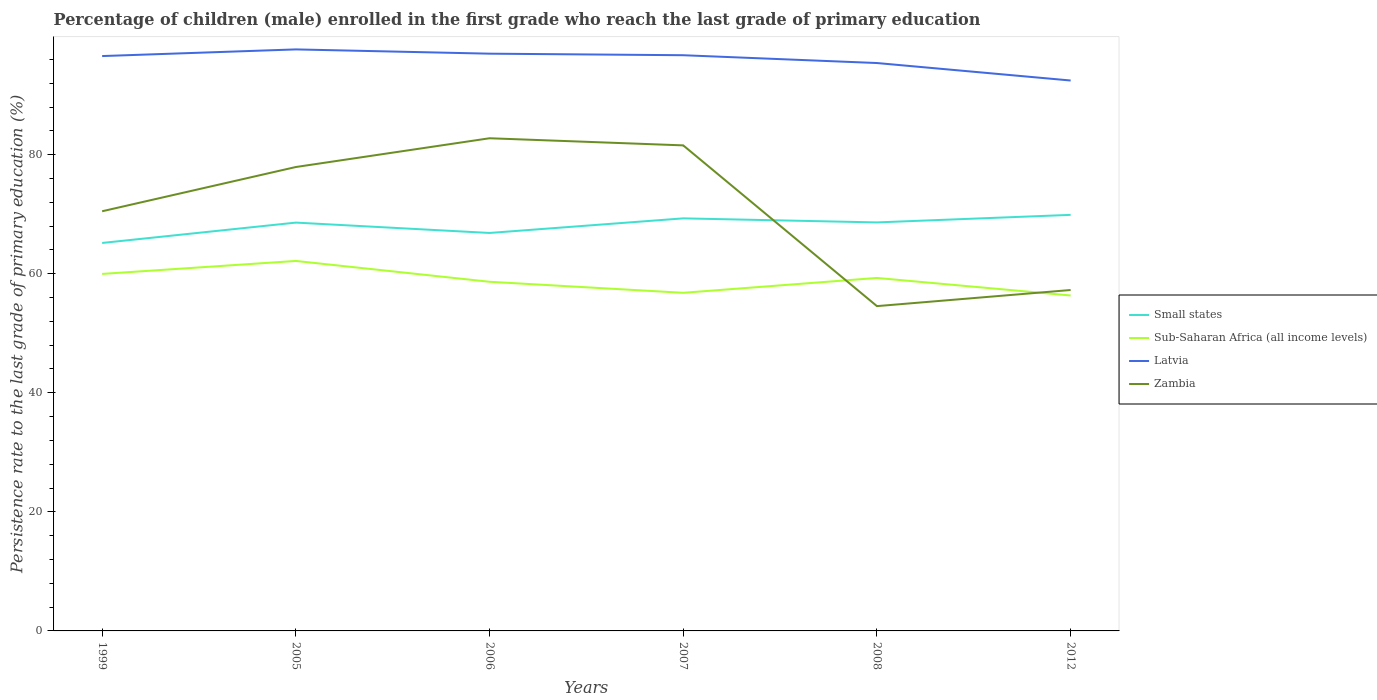Does the line corresponding to Latvia intersect with the line corresponding to Sub-Saharan Africa (all income levels)?
Make the answer very short. No. Is the number of lines equal to the number of legend labels?
Provide a succinct answer. Yes. Across all years, what is the maximum persistence rate of children in Sub-Saharan Africa (all income levels)?
Your answer should be very brief. 56.34. In which year was the persistence rate of children in Sub-Saharan Africa (all income levels) maximum?
Offer a terse response. 2012. What is the total persistence rate of children in Zambia in the graph?
Your answer should be very brief. -2.71. What is the difference between the highest and the second highest persistence rate of children in Latvia?
Provide a succinct answer. 5.23. How many years are there in the graph?
Provide a short and direct response. 6. Are the values on the major ticks of Y-axis written in scientific E-notation?
Your answer should be compact. No. Does the graph contain any zero values?
Give a very brief answer. No. How are the legend labels stacked?
Give a very brief answer. Vertical. What is the title of the graph?
Give a very brief answer. Percentage of children (male) enrolled in the first grade who reach the last grade of primary education. Does "Eritrea" appear as one of the legend labels in the graph?
Your answer should be compact. No. What is the label or title of the Y-axis?
Provide a short and direct response. Persistence rate to the last grade of primary education (%). What is the Persistence rate to the last grade of primary education (%) of Small states in 1999?
Give a very brief answer. 65.17. What is the Persistence rate to the last grade of primary education (%) of Sub-Saharan Africa (all income levels) in 1999?
Ensure brevity in your answer.  59.97. What is the Persistence rate to the last grade of primary education (%) in Latvia in 1999?
Keep it short and to the point. 96.56. What is the Persistence rate to the last grade of primary education (%) of Zambia in 1999?
Offer a terse response. 70.49. What is the Persistence rate to the last grade of primary education (%) in Small states in 2005?
Give a very brief answer. 68.59. What is the Persistence rate to the last grade of primary education (%) of Sub-Saharan Africa (all income levels) in 2005?
Your answer should be very brief. 62.15. What is the Persistence rate to the last grade of primary education (%) in Latvia in 2005?
Offer a very short reply. 97.68. What is the Persistence rate to the last grade of primary education (%) in Zambia in 2005?
Ensure brevity in your answer.  77.92. What is the Persistence rate to the last grade of primary education (%) of Small states in 2006?
Give a very brief answer. 66.85. What is the Persistence rate to the last grade of primary education (%) in Sub-Saharan Africa (all income levels) in 2006?
Your answer should be compact. 58.65. What is the Persistence rate to the last grade of primary education (%) in Latvia in 2006?
Ensure brevity in your answer.  96.96. What is the Persistence rate to the last grade of primary education (%) in Zambia in 2006?
Keep it short and to the point. 82.75. What is the Persistence rate to the last grade of primary education (%) of Small states in 2007?
Make the answer very short. 69.3. What is the Persistence rate to the last grade of primary education (%) of Sub-Saharan Africa (all income levels) in 2007?
Offer a very short reply. 56.8. What is the Persistence rate to the last grade of primary education (%) in Latvia in 2007?
Provide a succinct answer. 96.7. What is the Persistence rate to the last grade of primary education (%) in Zambia in 2007?
Give a very brief answer. 81.56. What is the Persistence rate to the last grade of primary education (%) in Small states in 2008?
Keep it short and to the point. 68.62. What is the Persistence rate to the last grade of primary education (%) in Sub-Saharan Africa (all income levels) in 2008?
Offer a very short reply. 59.29. What is the Persistence rate to the last grade of primary education (%) of Latvia in 2008?
Give a very brief answer. 95.39. What is the Persistence rate to the last grade of primary education (%) of Zambia in 2008?
Offer a very short reply. 54.56. What is the Persistence rate to the last grade of primary education (%) in Small states in 2012?
Provide a short and direct response. 69.89. What is the Persistence rate to the last grade of primary education (%) of Sub-Saharan Africa (all income levels) in 2012?
Make the answer very short. 56.34. What is the Persistence rate to the last grade of primary education (%) in Latvia in 2012?
Your answer should be compact. 92.45. What is the Persistence rate to the last grade of primary education (%) of Zambia in 2012?
Keep it short and to the point. 57.26. Across all years, what is the maximum Persistence rate to the last grade of primary education (%) of Small states?
Make the answer very short. 69.89. Across all years, what is the maximum Persistence rate to the last grade of primary education (%) in Sub-Saharan Africa (all income levels)?
Your answer should be very brief. 62.15. Across all years, what is the maximum Persistence rate to the last grade of primary education (%) of Latvia?
Your answer should be very brief. 97.68. Across all years, what is the maximum Persistence rate to the last grade of primary education (%) in Zambia?
Your answer should be very brief. 82.75. Across all years, what is the minimum Persistence rate to the last grade of primary education (%) in Small states?
Your response must be concise. 65.17. Across all years, what is the minimum Persistence rate to the last grade of primary education (%) of Sub-Saharan Africa (all income levels)?
Your answer should be very brief. 56.34. Across all years, what is the minimum Persistence rate to the last grade of primary education (%) in Latvia?
Your response must be concise. 92.45. Across all years, what is the minimum Persistence rate to the last grade of primary education (%) of Zambia?
Keep it short and to the point. 54.56. What is the total Persistence rate to the last grade of primary education (%) of Small states in the graph?
Give a very brief answer. 408.41. What is the total Persistence rate to the last grade of primary education (%) of Sub-Saharan Africa (all income levels) in the graph?
Give a very brief answer. 353.19. What is the total Persistence rate to the last grade of primary education (%) in Latvia in the graph?
Your answer should be compact. 575.74. What is the total Persistence rate to the last grade of primary education (%) of Zambia in the graph?
Your answer should be compact. 424.55. What is the difference between the Persistence rate to the last grade of primary education (%) in Small states in 1999 and that in 2005?
Ensure brevity in your answer.  -3.42. What is the difference between the Persistence rate to the last grade of primary education (%) in Sub-Saharan Africa (all income levels) in 1999 and that in 2005?
Provide a short and direct response. -2.18. What is the difference between the Persistence rate to the last grade of primary education (%) in Latvia in 1999 and that in 2005?
Provide a short and direct response. -1.12. What is the difference between the Persistence rate to the last grade of primary education (%) of Zambia in 1999 and that in 2005?
Make the answer very short. -7.43. What is the difference between the Persistence rate to the last grade of primary education (%) in Small states in 1999 and that in 2006?
Offer a terse response. -1.68. What is the difference between the Persistence rate to the last grade of primary education (%) in Sub-Saharan Africa (all income levels) in 1999 and that in 2006?
Give a very brief answer. 1.32. What is the difference between the Persistence rate to the last grade of primary education (%) of Latvia in 1999 and that in 2006?
Give a very brief answer. -0.4. What is the difference between the Persistence rate to the last grade of primary education (%) of Zambia in 1999 and that in 2006?
Make the answer very short. -12.26. What is the difference between the Persistence rate to the last grade of primary education (%) in Small states in 1999 and that in 2007?
Provide a short and direct response. -4.13. What is the difference between the Persistence rate to the last grade of primary education (%) in Sub-Saharan Africa (all income levels) in 1999 and that in 2007?
Your answer should be very brief. 3.17. What is the difference between the Persistence rate to the last grade of primary education (%) in Latvia in 1999 and that in 2007?
Make the answer very short. -0.14. What is the difference between the Persistence rate to the last grade of primary education (%) of Zambia in 1999 and that in 2007?
Your response must be concise. -11.07. What is the difference between the Persistence rate to the last grade of primary education (%) in Small states in 1999 and that in 2008?
Provide a short and direct response. -3.45. What is the difference between the Persistence rate to the last grade of primary education (%) in Sub-Saharan Africa (all income levels) in 1999 and that in 2008?
Your answer should be compact. 0.68. What is the difference between the Persistence rate to the last grade of primary education (%) of Latvia in 1999 and that in 2008?
Make the answer very short. 1.17. What is the difference between the Persistence rate to the last grade of primary education (%) of Zambia in 1999 and that in 2008?
Provide a short and direct response. 15.93. What is the difference between the Persistence rate to the last grade of primary education (%) in Small states in 1999 and that in 2012?
Keep it short and to the point. -4.72. What is the difference between the Persistence rate to the last grade of primary education (%) in Sub-Saharan Africa (all income levels) in 1999 and that in 2012?
Give a very brief answer. 3.63. What is the difference between the Persistence rate to the last grade of primary education (%) in Latvia in 1999 and that in 2012?
Keep it short and to the point. 4.11. What is the difference between the Persistence rate to the last grade of primary education (%) in Zambia in 1999 and that in 2012?
Make the answer very short. 13.23. What is the difference between the Persistence rate to the last grade of primary education (%) of Small states in 2005 and that in 2006?
Your answer should be very brief. 1.74. What is the difference between the Persistence rate to the last grade of primary education (%) of Sub-Saharan Africa (all income levels) in 2005 and that in 2006?
Provide a succinct answer. 3.5. What is the difference between the Persistence rate to the last grade of primary education (%) in Latvia in 2005 and that in 2006?
Make the answer very short. 0.72. What is the difference between the Persistence rate to the last grade of primary education (%) of Zambia in 2005 and that in 2006?
Make the answer very short. -4.83. What is the difference between the Persistence rate to the last grade of primary education (%) in Small states in 2005 and that in 2007?
Your answer should be compact. -0.71. What is the difference between the Persistence rate to the last grade of primary education (%) of Sub-Saharan Africa (all income levels) in 2005 and that in 2007?
Provide a succinct answer. 5.35. What is the difference between the Persistence rate to the last grade of primary education (%) in Zambia in 2005 and that in 2007?
Offer a very short reply. -3.63. What is the difference between the Persistence rate to the last grade of primary education (%) in Small states in 2005 and that in 2008?
Keep it short and to the point. -0.03. What is the difference between the Persistence rate to the last grade of primary education (%) in Sub-Saharan Africa (all income levels) in 2005 and that in 2008?
Your answer should be compact. 2.86. What is the difference between the Persistence rate to the last grade of primary education (%) of Latvia in 2005 and that in 2008?
Give a very brief answer. 2.29. What is the difference between the Persistence rate to the last grade of primary education (%) in Zambia in 2005 and that in 2008?
Offer a very short reply. 23.36. What is the difference between the Persistence rate to the last grade of primary education (%) in Small states in 2005 and that in 2012?
Keep it short and to the point. -1.3. What is the difference between the Persistence rate to the last grade of primary education (%) in Sub-Saharan Africa (all income levels) in 2005 and that in 2012?
Make the answer very short. 5.8. What is the difference between the Persistence rate to the last grade of primary education (%) in Latvia in 2005 and that in 2012?
Ensure brevity in your answer.  5.23. What is the difference between the Persistence rate to the last grade of primary education (%) of Zambia in 2005 and that in 2012?
Offer a very short reply. 20.66. What is the difference between the Persistence rate to the last grade of primary education (%) in Small states in 2006 and that in 2007?
Your answer should be compact. -2.45. What is the difference between the Persistence rate to the last grade of primary education (%) of Sub-Saharan Africa (all income levels) in 2006 and that in 2007?
Your response must be concise. 1.85. What is the difference between the Persistence rate to the last grade of primary education (%) in Latvia in 2006 and that in 2007?
Provide a succinct answer. 0.26. What is the difference between the Persistence rate to the last grade of primary education (%) of Zambia in 2006 and that in 2007?
Provide a short and direct response. 1.2. What is the difference between the Persistence rate to the last grade of primary education (%) of Small states in 2006 and that in 2008?
Provide a short and direct response. -1.77. What is the difference between the Persistence rate to the last grade of primary education (%) in Sub-Saharan Africa (all income levels) in 2006 and that in 2008?
Your answer should be compact. -0.64. What is the difference between the Persistence rate to the last grade of primary education (%) of Latvia in 2006 and that in 2008?
Make the answer very short. 1.57. What is the difference between the Persistence rate to the last grade of primary education (%) of Zambia in 2006 and that in 2008?
Keep it short and to the point. 28.2. What is the difference between the Persistence rate to the last grade of primary education (%) of Small states in 2006 and that in 2012?
Your answer should be very brief. -3.04. What is the difference between the Persistence rate to the last grade of primary education (%) in Sub-Saharan Africa (all income levels) in 2006 and that in 2012?
Your answer should be compact. 2.3. What is the difference between the Persistence rate to the last grade of primary education (%) in Latvia in 2006 and that in 2012?
Offer a very short reply. 4.51. What is the difference between the Persistence rate to the last grade of primary education (%) in Zambia in 2006 and that in 2012?
Offer a terse response. 25.49. What is the difference between the Persistence rate to the last grade of primary education (%) of Small states in 2007 and that in 2008?
Make the answer very short. 0.68. What is the difference between the Persistence rate to the last grade of primary education (%) in Sub-Saharan Africa (all income levels) in 2007 and that in 2008?
Your answer should be compact. -2.5. What is the difference between the Persistence rate to the last grade of primary education (%) in Latvia in 2007 and that in 2008?
Keep it short and to the point. 1.31. What is the difference between the Persistence rate to the last grade of primary education (%) in Zambia in 2007 and that in 2008?
Your answer should be very brief. 27. What is the difference between the Persistence rate to the last grade of primary education (%) in Small states in 2007 and that in 2012?
Give a very brief answer. -0.59. What is the difference between the Persistence rate to the last grade of primary education (%) in Sub-Saharan Africa (all income levels) in 2007 and that in 2012?
Offer a very short reply. 0.45. What is the difference between the Persistence rate to the last grade of primary education (%) of Latvia in 2007 and that in 2012?
Make the answer very short. 4.25. What is the difference between the Persistence rate to the last grade of primary education (%) in Zambia in 2007 and that in 2012?
Your response must be concise. 24.29. What is the difference between the Persistence rate to the last grade of primary education (%) of Small states in 2008 and that in 2012?
Your answer should be compact. -1.27. What is the difference between the Persistence rate to the last grade of primary education (%) in Sub-Saharan Africa (all income levels) in 2008 and that in 2012?
Ensure brevity in your answer.  2.95. What is the difference between the Persistence rate to the last grade of primary education (%) of Latvia in 2008 and that in 2012?
Keep it short and to the point. 2.94. What is the difference between the Persistence rate to the last grade of primary education (%) in Zambia in 2008 and that in 2012?
Your response must be concise. -2.71. What is the difference between the Persistence rate to the last grade of primary education (%) in Small states in 1999 and the Persistence rate to the last grade of primary education (%) in Sub-Saharan Africa (all income levels) in 2005?
Provide a succinct answer. 3.02. What is the difference between the Persistence rate to the last grade of primary education (%) of Small states in 1999 and the Persistence rate to the last grade of primary education (%) of Latvia in 2005?
Make the answer very short. -32.51. What is the difference between the Persistence rate to the last grade of primary education (%) in Small states in 1999 and the Persistence rate to the last grade of primary education (%) in Zambia in 2005?
Your answer should be very brief. -12.76. What is the difference between the Persistence rate to the last grade of primary education (%) in Sub-Saharan Africa (all income levels) in 1999 and the Persistence rate to the last grade of primary education (%) in Latvia in 2005?
Provide a short and direct response. -37.71. What is the difference between the Persistence rate to the last grade of primary education (%) in Sub-Saharan Africa (all income levels) in 1999 and the Persistence rate to the last grade of primary education (%) in Zambia in 2005?
Offer a terse response. -17.95. What is the difference between the Persistence rate to the last grade of primary education (%) of Latvia in 1999 and the Persistence rate to the last grade of primary education (%) of Zambia in 2005?
Keep it short and to the point. 18.64. What is the difference between the Persistence rate to the last grade of primary education (%) in Small states in 1999 and the Persistence rate to the last grade of primary education (%) in Sub-Saharan Africa (all income levels) in 2006?
Provide a short and direct response. 6.52. What is the difference between the Persistence rate to the last grade of primary education (%) in Small states in 1999 and the Persistence rate to the last grade of primary education (%) in Latvia in 2006?
Your answer should be very brief. -31.79. What is the difference between the Persistence rate to the last grade of primary education (%) of Small states in 1999 and the Persistence rate to the last grade of primary education (%) of Zambia in 2006?
Ensure brevity in your answer.  -17.59. What is the difference between the Persistence rate to the last grade of primary education (%) in Sub-Saharan Africa (all income levels) in 1999 and the Persistence rate to the last grade of primary education (%) in Latvia in 2006?
Keep it short and to the point. -36.99. What is the difference between the Persistence rate to the last grade of primary education (%) in Sub-Saharan Africa (all income levels) in 1999 and the Persistence rate to the last grade of primary education (%) in Zambia in 2006?
Keep it short and to the point. -22.79. What is the difference between the Persistence rate to the last grade of primary education (%) in Latvia in 1999 and the Persistence rate to the last grade of primary education (%) in Zambia in 2006?
Ensure brevity in your answer.  13.81. What is the difference between the Persistence rate to the last grade of primary education (%) in Small states in 1999 and the Persistence rate to the last grade of primary education (%) in Sub-Saharan Africa (all income levels) in 2007?
Make the answer very short. 8.37. What is the difference between the Persistence rate to the last grade of primary education (%) in Small states in 1999 and the Persistence rate to the last grade of primary education (%) in Latvia in 2007?
Keep it short and to the point. -31.53. What is the difference between the Persistence rate to the last grade of primary education (%) in Small states in 1999 and the Persistence rate to the last grade of primary education (%) in Zambia in 2007?
Ensure brevity in your answer.  -16.39. What is the difference between the Persistence rate to the last grade of primary education (%) of Sub-Saharan Africa (all income levels) in 1999 and the Persistence rate to the last grade of primary education (%) of Latvia in 2007?
Give a very brief answer. -36.73. What is the difference between the Persistence rate to the last grade of primary education (%) in Sub-Saharan Africa (all income levels) in 1999 and the Persistence rate to the last grade of primary education (%) in Zambia in 2007?
Your response must be concise. -21.59. What is the difference between the Persistence rate to the last grade of primary education (%) in Latvia in 1999 and the Persistence rate to the last grade of primary education (%) in Zambia in 2007?
Give a very brief answer. 15. What is the difference between the Persistence rate to the last grade of primary education (%) of Small states in 1999 and the Persistence rate to the last grade of primary education (%) of Sub-Saharan Africa (all income levels) in 2008?
Give a very brief answer. 5.88. What is the difference between the Persistence rate to the last grade of primary education (%) of Small states in 1999 and the Persistence rate to the last grade of primary education (%) of Latvia in 2008?
Keep it short and to the point. -30.22. What is the difference between the Persistence rate to the last grade of primary education (%) of Small states in 1999 and the Persistence rate to the last grade of primary education (%) of Zambia in 2008?
Provide a succinct answer. 10.61. What is the difference between the Persistence rate to the last grade of primary education (%) in Sub-Saharan Africa (all income levels) in 1999 and the Persistence rate to the last grade of primary education (%) in Latvia in 2008?
Your response must be concise. -35.42. What is the difference between the Persistence rate to the last grade of primary education (%) in Sub-Saharan Africa (all income levels) in 1999 and the Persistence rate to the last grade of primary education (%) in Zambia in 2008?
Give a very brief answer. 5.41. What is the difference between the Persistence rate to the last grade of primary education (%) in Latvia in 1999 and the Persistence rate to the last grade of primary education (%) in Zambia in 2008?
Offer a very short reply. 42. What is the difference between the Persistence rate to the last grade of primary education (%) of Small states in 1999 and the Persistence rate to the last grade of primary education (%) of Sub-Saharan Africa (all income levels) in 2012?
Provide a succinct answer. 8.82. What is the difference between the Persistence rate to the last grade of primary education (%) of Small states in 1999 and the Persistence rate to the last grade of primary education (%) of Latvia in 2012?
Keep it short and to the point. -27.28. What is the difference between the Persistence rate to the last grade of primary education (%) in Small states in 1999 and the Persistence rate to the last grade of primary education (%) in Zambia in 2012?
Keep it short and to the point. 7.9. What is the difference between the Persistence rate to the last grade of primary education (%) of Sub-Saharan Africa (all income levels) in 1999 and the Persistence rate to the last grade of primary education (%) of Latvia in 2012?
Your answer should be compact. -32.48. What is the difference between the Persistence rate to the last grade of primary education (%) in Sub-Saharan Africa (all income levels) in 1999 and the Persistence rate to the last grade of primary education (%) in Zambia in 2012?
Your response must be concise. 2.71. What is the difference between the Persistence rate to the last grade of primary education (%) of Latvia in 1999 and the Persistence rate to the last grade of primary education (%) of Zambia in 2012?
Offer a very short reply. 39.3. What is the difference between the Persistence rate to the last grade of primary education (%) of Small states in 2005 and the Persistence rate to the last grade of primary education (%) of Sub-Saharan Africa (all income levels) in 2006?
Provide a short and direct response. 9.94. What is the difference between the Persistence rate to the last grade of primary education (%) of Small states in 2005 and the Persistence rate to the last grade of primary education (%) of Latvia in 2006?
Your answer should be very brief. -28.37. What is the difference between the Persistence rate to the last grade of primary education (%) in Small states in 2005 and the Persistence rate to the last grade of primary education (%) in Zambia in 2006?
Provide a succinct answer. -14.17. What is the difference between the Persistence rate to the last grade of primary education (%) of Sub-Saharan Africa (all income levels) in 2005 and the Persistence rate to the last grade of primary education (%) of Latvia in 2006?
Make the answer very short. -34.81. What is the difference between the Persistence rate to the last grade of primary education (%) of Sub-Saharan Africa (all income levels) in 2005 and the Persistence rate to the last grade of primary education (%) of Zambia in 2006?
Give a very brief answer. -20.61. What is the difference between the Persistence rate to the last grade of primary education (%) of Latvia in 2005 and the Persistence rate to the last grade of primary education (%) of Zambia in 2006?
Offer a terse response. 14.92. What is the difference between the Persistence rate to the last grade of primary education (%) of Small states in 2005 and the Persistence rate to the last grade of primary education (%) of Sub-Saharan Africa (all income levels) in 2007?
Give a very brief answer. 11.79. What is the difference between the Persistence rate to the last grade of primary education (%) of Small states in 2005 and the Persistence rate to the last grade of primary education (%) of Latvia in 2007?
Your answer should be very brief. -28.11. What is the difference between the Persistence rate to the last grade of primary education (%) of Small states in 2005 and the Persistence rate to the last grade of primary education (%) of Zambia in 2007?
Your answer should be compact. -12.97. What is the difference between the Persistence rate to the last grade of primary education (%) in Sub-Saharan Africa (all income levels) in 2005 and the Persistence rate to the last grade of primary education (%) in Latvia in 2007?
Make the answer very short. -34.55. What is the difference between the Persistence rate to the last grade of primary education (%) in Sub-Saharan Africa (all income levels) in 2005 and the Persistence rate to the last grade of primary education (%) in Zambia in 2007?
Provide a succinct answer. -19.41. What is the difference between the Persistence rate to the last grade of primary education (%) in Latvia in 2005 and the Persistence rate to the last grade of primary education (%) in Zambia in 2007?
Your response must be concise. 16.12. What is the difference between the Persistence rate to the last grade of primary education (%) in Small states in 2005 and the Persistence rate to the last grade of primary education (%) in Sub-Saharan Africa (all income levels) in 2008?
Keep it short and to the point. 9.3. What is the difference between the Persistence rate to the last grade of primary education (%) of Small states in 2005 and the Persistence rate to the last grade of primary education (%) of Latvia in 2008?
Offer a very short reply. -26.8. What is the difference between the Persistence rate to the last grade of primary education (%) of Small states in 2005 and the Persistence rate to the last grade of primary education (%) of Zambia in 2008?
Give a very brief answer. 14.03. What is the difference between the Persistence rate to the last grade of primary education (%) in Sub-Saharan Africa (all income levels) in 2005 and the Persistence rate to the last grade of primary education (%) in Latvia in 2008?
Offer a very short reply. -33.24. What is the difference between the Persistence rate to the last grade of primary education (%) in Sub-Saharan Africa (all income levels) in 2005 and the Persistence rate to the last grade of primary education (%) in Zambia in 2008?
Offer a very short reply. 7.59. What is the difference between the Persistence rate to the last grade of primary education (%) in Latvia in 2005 and the Persistence rate to the last grade of primary education (%) in Zambia in 2008?
Keep it short and to the point. 43.12. What is the difference between the Persistence rate to the last grade of primary education (%) in Small states in 2005 and the Persistence rate to the last grade of primary education (%) in Sub-Saharan Africa (all income levels) in 2012?
Your response must be concise. 12.24. What is the difference between the Persistence rate to the last grade of primary education (%) in Small states in 2005 and the Persistence rate to the last grade of primary education (%) in Latvia in 2012?
Provide a short and direct response. -23.87. What is the difference between the Persistence rate to the last grade of primary education (%) in Small states in 2005 and the Persistence rate to the last grade of primary education (%) in Zambia in 2012?
Make the answer very short. 11.32. What is the difference between the Persistence rate to the last grade of primary education (%) in Sub-Saharan Africa (all income levels) in 2005 and the Persistence rate to the last grade of primary education (%) in Latvia in 2012?
Offer a terse response. -30.31. What is the difference between the Persistence rate to the last grade of primary education (%) in Sub-Saharan Africa (all income levels) in 2005 and the Persistence rate to the last grade of primary education (%) in Zambia in 2012?
Offer a terse response. 4.88. What is the difference between the Persistence rate to the last grade of primary education (%) in Latvia in 2005 and the Persistence rate to the last grade of primary education (%) in Zambia in 2012?
Your answer should be compact. 40.41. What is the difference between the Persistence rate to the last grade of primary education (%) of Small states in 2006 and the Persistence rate to the last grade of primary education (%) of Sub-Saharan Africa (all income levels) in 2007?
Your response must be concise. 10.05. What is the difference between the Persistence rate to the last grade of primary education (%) in Small states in 2006 and the Persistence rate to the last grade of primary education (%) in Latvia in 2007?
Keep it short and to the point. -29.85. What is the difference between the Persistence rate to the last grade of primary education (%) in Small states in 2006 and the Persistence rate to the last grade of primary education (%) in Zambia in 2007?
Offer a very short reply. -14.71. What is the difference between the Persistence rate to the last grade of primary education (%) in Sub-Saharan Africa (all income levels) in 2006 and the Persistence rate to the last grade of primary education (%) in Latvia in 2007?
Provide a short and direct response. -38.05. What is the difference between the Persistence rate to the last grade of primary education (%) of Sub-Saharan Africa (all income levels) in 2006 and the Persistence rate to the last grade of primary education (%) of Zambia in 2007?
Offer a very short reply. -22.91. What is the difference between the Persistence rate to the last grade of primary education (%) in Latvia in 2006 and the Persistence rate to the last grade of primary education (%) in Zambia in 2007?
Your answer should be very brief. 15.4. What is the difference between the Persistence rate to the last grade of primary education (%) in Small states in 2006 and the Persistence rate to the last grade of primary education (%) in Sub-Saharan Africa (all income levels) in 2008?
Your answer should be very brief. 7.56. What is the difference between the Persistence rate to the last grade of primary education (%) in Small states in 2006 and the Persistence rate to the last grade of primary education (%) in Latvia in 2008?
Offer a very short reply. -28.54. What is the difference between the Persistence rate to the last grade of primary education (%) of Small states in 2006 and the Persistence rate to the last grade of primary education (%) of Zambia in 2008?
Provide a short and direct response. 12.29. What is the difference between the Persistence rate to the last grade of primary education (%) of Sub-Saharan Africa (all income levels) in 2006 and the Persistence rate to the last grade of primary education (%) of Latvia in 2008?
Your answer should be very brief. -36.74. What is the difference between the Persistence rate to the last grade of primary education (%) of Sub-Saharan Africa (all income levels) in 2006 and the Persistence rate to the last grade of primary education (%) of Zambia in 2008?
Offer a very short reply. 4.09. What is the difference between the Persistence rate to the last grade of primary education (%) in Latvia in 2006 and the Persistence rate to the last grade of primary education (%) in Zambia in 2008?
Give a very brief answer. 42.4. What is the difference between the Persistence rate to the last grade of primary education (%) in Small states in 2006 and the Persistence rate to the last grade of primary education (%) in Sub-Saharan Africa (all income levels) in 2012?
Provide a short and direct response. 10.5. What is the difference between the Persistence rate to the last grade of primary education (%) of Small states in 2006 and the Persistence rate to the last grade of primary education (%) of Latvia in 2012?
Your answer should be very brief. -25.61. What is the difference between the Persistence rate to the last grade of primary education (%) in Small states in 2006 and the Persistence rate to the last grade of primary education (%) in Zambia in 2012?
Your answer should be very brief. 9.58. What is the difference between the Persistence rate to the last grade of primary education (%) of Sub-Saharan Africa (all income levels) in 2006 and the Persistence rate to the last grade of primary education (%) of Latvia in 2012?
Make the answer very short. -33.8. What is the difference between the Persistence rate to the last grade of primary education (%) of Sub-Saharan Africa (all income levels) in 2006 and the Persistence rate to the last grade of primary education (%) of Zambia in 2012?
Give a very brief answer. 1.38. What is the difference between the Persistence rate to the last grade of primary education (%) of Latvia in 2006 and the Persistence rate to the last grade of primary education (%) of Zambia in 2012?
Make the answer very short. 39.7. What is the difference between the Persistence rate to the last grade of primary education (%) of Small states in 2007 and the Persistence rate to the last grade of primary education (%) of Sub-Saharan Africa (all income levels) in 2008?
Provide a succinct answer. 10.01. What is the difference between the Persistence rate to the last grade of primary education (%) in Small states in 2007 and the Persistence rate to the last grade of primary education (%) in Latvia in 2008?
Your answer should be compact. -26.09. What is the difference between the Persistence rate to the last grade of primary education (%) in Small states in 2007 and the Persistence rate to the last grade of primary education (%) in Zambia in 2008?
Make the answer very short. 14.74. What is the difference between the Persistence rate to the last grade of primary education (%) of Sub-Saharan Africa (all income levels) in 2007 and the Persistence rate to the last grade of primary education (%) of Latvia in 2008?
Your answer should be very brief. -38.59. What is the difference between the Persistence rate to the last grade of primary education (%) in Sub-Saharan Africa (all income levels) in 2007 and the Persistence rate to the last grade of primary education (%) in Zambia in 2008?
Keep it short and to the point. 2.24. What is the difference between the Persistence rate to the last grade of primary education (%) of Latvia in 2007 and the Persistence rate to the last grade of primary education (%) of Zambia in 2008?
Your response must be concise. 42.14. What is the difference between the Persistence rate to the last grade of primary education (%) in Small states in 2007 and the Persistence rate to the last grade of primary education (%) in Sub-Saharan Africa (all income levels) in 2012?
Your answer should be compact. 12.96. What is the difference between the Persistence rate to the last grade of primary education (%) in Small states in 2007 and the Persistence rate to the last grade of primary education (%) in Latvia in 2012?
Your answer should be very brief. -23.15. What is the difference between the Persistence rate to the last grade of primary education (%) in Small states in 2007 and the Persistence rate to the last grade of primary education (%) in Zambia in 2012?
Ensure brevity in your answer.  12.04. What is the difference between the Persistence rate to the last grade of primary education (%) in Sub-Saharan Africa (all income levels) in 2007 and the Persistence rate to the last grade of primary education (%) in Latvia in 2012?
Your answer should be very brief. -35.66. What is the difference between the Persistence rate to the last grade of primary education (%) in Sub-Saharan Africa (all income levels) in 2007 and the Persistence rate to the last grade of primary education (%) in Zambia in 2012?
Offer a very short reply. -0.47. What is the difference between the Persistence rate to the last grade of primary education (%) in Latvia in 2007 and the Persistence rate to the last grade of primary education (%) in Zambia in 2012?
Make the answer very short. 39.44. What is the difference between the Persistence rate to the last grade of primary education (%) of Small states in 2008 and the Persistence rate to the last grade of primary education (%) of Sub-Saharan Africa (all income levels) in 2012?
Offer a very short reply. 12.28. What is the difference between the Persistence rate to the last grade of primary education (%) of Small states in 2008 and the Persistence rate to the last grade of primary education (%) of Latvia in 2012?
Keep it short and to the point. -23.83. What is the difference between the Persistence rate to the last grade of primary education (%) in Small states in 2008 and the Persistence rate to the last grade of primary education (%) in Zambia in 2012?
Your answer should be compact. 11.36. What is the difference between the Persistence rate to the last grade of primary education (%) of Sub-Saharan Africa (all income levels) in 2008 and the Persistence rate to the last grade of primary education (%) of Latvia in 2012?
Your response must be concise. -33.16. What is the difference between the Persistence rate to the last grade of primary education (%) in Sub-Saharan Africa (all income levels) in 2008 and the Persistence rate to the last grade of primary education (%) in Zambia in 2012?
Your response must be concise. 2.03. What is the difference between the Persistence rate to the last grade of primary education (%) of Latvia in 2008 and the Persistence rate to the last grade of primary education (%) of Zambia in 2012?
Ensure brevity in your answer.  38.13. What is the average Persistence rate to the last grade of primary education (%) of Small states per year?
Your answer should be very brief. 68.07. What is the average Persistence rate to the last grade of primary education (%) in Sub-Saharan Africa (all income levels) per year?
Provide a succinct answer. 58.87. What is the average Persistence rate to the last grade of primary education (%) in Latvia per year?
Make the answer very short. 95.96. What is the average Persistence rate to the last grade of primary education (%) of Zambia per year?
Keep it short and to the point. 70.76. In the year 1999, what is the difference between the Persistence rate to the last grade of primary education (%) of Small states and Persistence rate to the last grade of primary education (%) of Sub-Saharan Africa (all income levels)?
Give a very brief answer. 5.2. In the year 1999, what is the difference between the Persistence rate to the last grade of primary education (%) of Small states and Persistence rate to the last grade of primary education (%) of Latvia?
Keep it short and to the point. -31.39. In the year 1999, what is the difference between the Persistence rate to the last grade of primary education (%) of Small states and Persistence rate to the last grade of primary education (%) of Zambia?
Provide a succinct answer. -5.32. In the year 1999, what is the difference between the Persistence rate to the last grade of primary education (%) of Sub-Saharan Africa (all income levels) and Persistence rate to the last grade of primary education (%) of Latvia?
Provide a succinct answer. -36.59. In the year 1999, what is the difference between the Persistence rate to the last grade of primary education (%) of Sub-Saharan Africa (all income levels) and Persistence rate to the last grade of primary education (%) of Zambia?
Your answer should be compact. -10.52. In the year 1999, what is the difference between the Persistence rate to the last grade of primary education (%) in Latvia and Persistence rate to the last grade of primary education (%) in Zambia?
Provide a succinct answer. 26.07. In the year 2005, what is the difference between the Persistence rate to the last grade of primary education (%) in Small states and Persistence rate to the last grade of primary education (%) in Sub-Saharan Africa (all income levels)?
Give a very brief answer. 6.44. In the year 2005, what is the difference between the Persistence rate to the last grade of primary education (%) of Small states and Persistence rate to the last grade of primary education (%) of Latvia?
Keep it short and to the point. -29.09. In the year 2005, what is the difference between the Persistence rate to the last grade of primary education (%) of Small states and Persistence rate to the last grade of primary education (%) of Zambia?
Provide a succinct answer. -9.34. In the year 2005, what is the difference between the Persistence rate to the last grade of primary education (%) of Sub-Saharan Africa (all income levels) and Persistence rate to the last grade of primary education (%) of Latvia?
Offer a terse response. -35.53. In the year 2005, what is the difference between the Persistence rate to the last grade of primary education (%) in Sub-Saharan Africa (all income levels) and Persistence rate to the last grade of primary education (%) in Zambia?
Your answer should be compact. -15.78. In the year 2005, what is the difference between the Persistence rate to the last grade of primary education (%) in Latvia and Persistence rate to the last grade of primary education (%) in Zambia?
Your response must be concise. 19.75. In the year 2006, what is the difference between the Persistence rate to the last grade of primary education (%) in Small states and Persistence rate to the last grade of primary education (%) in Sub-Saharan Africa (all income levels)?
Your response must be concise. 8.2. In the year 2006, what is the difference between the Persistence rate to the last grade of primary education (%) of Small states and Persistence rate to the last grade of primary education (%) of Latvia?
Keep it short and to the point. -30.11. In the year 2006, what is the difference between the Persistence rate to the last grade of primary education (%) of Small states and Persistence rate to the last grade of primary education (%) of Zambia?
Give a very brief answer. -15.91. In the year 2006, what is the difference between the Persistence rate to the last grade of primary education (%) of Sub-Saharan Africa (all income levels) and Persistence rate to the last grade of primary education (%) of Latvia?
Offer a very short reply. -38.31. In the year 2006, what is the difference between the Persistence rate to the last grade of primary education (%) in Sub-Saharan Africa (all income levels) and Persistence rate to the last grade of primary education (%) in Zambia?
Provide a short and direct response. -24.11. In the year 2006, what is the difference between the Persistence rate to the last grade of primary education (%) of Latvia and Persistence rate to the last grade of primary education (%) of Zambia?
Make the answer very short. 14.21. In the year 2007, what is the difference between the Persistence rate to the last grade of primary education (%) in Small states and Persistence rate to the last grade of primary education (%) in Sub-Saharan Africa (all income levels)?
Keep it short and to the point. 12.5. In the year 2007, what is the difference between the Persistence rate to the last grade of primary education (%) of Small states and Persistence rate to the last grade of primary education (%) of Latvia?
Provide a succinct answer. -27.4. In the year 2007, what is the difference between the Persistence rate to the last grade of primary education (%) in Small states and Persistence rate to the last grade of primary education (%) in Zambia?
Your answer should be compact. -12.26. In the year 2007, what is the difference between the Persistence rate to the last grade of primary education (%) of Sub-Saharan Africa (all income levels) and Persistence rate to the last grade of primary education (%) of Latvia?
Your answer should be very brief. -39.9. In the year 2007, what is the difference between the Persistence rate to the last grade of primary education (%) of Sub-Saharan Africa (all income levels) and Persistence rate to the last grade of primary education (%) of Zambia?
Your answer should be very brief. -24.76. In the year 2007, what is the difference between the Persistence rate to the last grade of primary education (%) of Latvia and Persistence rate to the last grade of primary education (%) of Zambia?
Your answer should be compact. 15.14. In the year 2008, what is the difference between the Persistence rate to the last grade of primary education (%) of Small states and Persistence rate to the last grade of primary education (%) of Sub-Saharan Africa (all income levels)?
Keep it short and to the point. 9.33. In the year 2008, what is the difference between the Persistence rate to the last grade of primary education (%) of Small states and Persistence rate to the last grade of primary education (%) of Latvia?
Provide a short and direct response. -26.77. In the year 2008, what is the difference between the Persistence rate to the last grade of primary education (%) in Small states and Persistence rate to the last grade of primary education (%) in Zambia?
Give a very brief answer. 14.06. In the year 2008, what is the difference between the Persistence rate to the last grade of primary education (%) in Sub-Saharan Africa (all income levels) and Persistence rate to the last grade of primary education (%) in Latvia?
Make the answer very short. -36.1. In the year 2008, what is the difference between the Persistence rate to the last grade of primary education (%) of Sub-Saharan Africa (all income levels) and Persistence rate to the last grade of primary education (%) of Zambia?
Ensure brevity in your answer.  4.73. In the year 2008, what is the difference between the Persistence rate to the last grade of primary education (%) in Latvia and Persistence rate to the last grade of primary education (%) in Zambia?
Provide a succinct answer. 40.83. In the year 2012, what is the difference between the Persistence rate to the last grade of primary education (%) in Small states and Persistence rate to the last grade of primary education (%) in Sub-Saharan Africa (all income levels)?
Your answer should be very brief. 13.54. In the year 2012, what is the difference between the Persistence rate to the last grade of primary education (%) of Small states and Persistence rate to the last grade of primary education (%) of Latvia?
Provide a short and direct response. -22.57. In the year 2012, what is the difference between the Persistence rate to the last grade of primary education (%) of Small states and Persistence rate to the last grade of primary education (%) of Zambia?
Offer a terse response. 12.62. In the year 2012, what is the difference between the Persistence rate to the last grade of primary education (%) in Sub-Saharan Africa (all income levels) and Persistence rate to the last grade of primary education (%) in Latvia?
Offer a very short reply. -36.11. In the year 2012, what is the difference between the Persistence rate to the last grade of primary education (%) in Sub-Saharan Africa (all income levels) and Persistence rate to the last grade of primary education (%) in Zambia?
Provide a succinct answer. -0.92. In the year 2012, what is the difference between the Persistence rate to the last grade of primary education (%) in Latvia and Persistence rate to the last grade of primary education (%) in Zambia?
Keep it short and to the point. 35.19. What is the ratio of the Persistence rate to the last grade of primary education (%) in Small states in 1999 to that in 2005?
Your answer should be compact. 0.95. What is the ratio of the Persistence rate to the last grade of primary education (%) of Sub-Saharan Africa (all income levels) in 1999 to that in 2005?
Give a very brief answer. 0.96. What is the ratio of the Persistence rate to the last grade of primary education (%) in Latvia in 1999 to that in 2005?
Offer a terse response. 0.99. What is the ratio of the Persistence rate to the last grade of primary education (%) of Zambia in 1999 to that in 2005?
Provide a succinct answer. 0.9. What is the ratio of the Persistence rate to the last grade of primary education (%) of Small states in 1999 to that in 2006?
Make the answer very short. 0.97. What is the ratio of the Persistence rate to the last grade of primary education (%) in Sub-Saharan Africa (all income levels) in 1999 to that in 2006?
Make the answer very short. 1.02. What is the ratio of the Persistence rate to the last grade of primary education (%) of Zambia in 1999 to that in 2006?
Your answer should be very brief. 0.85. What is the ratio of the Persistence rate to the last grade of primary education (%) in Small states in 1999 to that in 2007?
Ensure brevity in your answer.  0.94. What is the ratio of the Persistence rate to the last grade of primary education (%) of Sub-Saharan Africa (all income levels) in 1999 to that in 2007?
Provide a short and direct response. 1.06. What is the ratio of the Persistence rate to the last grade of primary education (%) in Zambia in 1999 to that in 2007?
Your response must be concise. 0.86. What is the ratio of the Persistence rate to the last grade of primary education (%) of Small states in 1999 to that in 2008?
Your answer should be very brief. 0.95. What is the ratio of the Persistence rate to the last grade of primary education (%) of Sub-Saharan Africa (all income levels) in 1999 to that in 2008?
Offer a very short reply. 1.01. What is the ratio of the Persistence rate to the last grade of primary education (%) of Latvia in 1999 to that in 2008?
Give a very brief answer. 1.01. What is the ratio of the Persistence rate to the last grade of primary education (%) in Zambia in 1999 to that in 2008?
Your response must be concise. 1.29. What is the ratio of the Persistence rate to the last grade of primary education (%) of Small states in 1999 to that in 2012?
Offer a very short reply. 0.93. What is the ratio of the Persistence rate to the last grade of primary education (%) in Sub-Saharan Africa (all income levels) in 1999 to that in 2012?
Your answer should be compact. 1.06. What is the ratio of the Persistence rate to the last grade of primary education (%) of Latvia in 1999 to that in 2012?
Ensure brevity in your answer.  1.04. What is the ratio of the Persistence rate to the last grade of primary education (%) of Zambia in 1999 to that in 2012?
Offer a terse response. 1.23. What is the ratio of the Persistence rate to the last grade of primary education (%) of Small states in 2005 to that in 2006?
Make the answer very short. 1.03. What is the ratio of the Persistence rate to the last grade of primary education (%) in Sub-Saharan Africa (all income levels) in 2005 to that in 2006?
Make the answer very short. 1.06. What is the ratio of the Persistence rate to the last grade of primary education (%) of Latvia in 2005 to that in 2006?
Offer a terse response. 1.01. What is the ratio of the Persistence rate to the last grade of primary education (%) of Zambia in 2005 to that in 2006?
Ensure brevity in your answer.  0.94. What is the ratio of the Persistence rate to the last grade of primary education (%) of Small states in 2005 to that in 2007?
Ensure brevity in your answer.  0.99. What is the ratio of the Persistence rate to the last grade of primary education (%) in Sub-Saharan Africa (all income levels) in 2005 to that in 2007?
Your response must be concise. 1.09. What is the ratio of the Persistence rate to the last grade of primary education (%) in Latvia in 2005 to that in 2007?
Provide a short and direct response. 1.01. What is the ratio of the Persistence rate to the last grade of primary education (%) in Zambia in 2005 to that in 2007?
Offer a very short reply. 0.96. What is the ratio of the Persistence rate to the last grade of primary education (%) of Small states in 2005 to that in 2008?
Ensure brevity in your answer.  1. What is the ratio of the Persistence rate to the last grade of primary education (%) of Sub-Saharan Africa (all income levels) in 2005 to that in 2008?
Your answer should be compact. 1.05. What is the ratio of the Persistence rate to the last grade of primary education (%) of Latvia in 2005 to that in 2008?
Offer a very short reply. 1.02. What is the ratio of the Persistence rate to the last grade of primary education (%) in Zambia in 2005 to that in 2008?
Provide a succinct answer. 1.43. What is the ratio of the Persistence rate to the last grade of primary education (%) in Small states in 2005 to that in 2012?
Make the answer very short. 0.98. What is the ratio of the Persistence rate to the last grade of primary education (%) of Sub-Saharan Africa (all income levels) in 2005 to that in 2012?
Your response must be concise. 1.1. What is the ratio of the Persistence rate to the last grade of primary education (%) of Latvia in 2005 to that in 2012?
Ensure brevity in your answer.  1.06. What is the ratio of the Persistence rate to the last grade of primary education (%) of Zambia in 2005 to that in 2012?
Ensure brevity in your answer.  1.36. What is the ratio of the Persistence rate to the last grade of primary education (%) in Small states in 2006 to that in 2007?
Your response must be concise. 0.96. What is the ratio of the Persistence rate to the last grade of primary education (%) of Sub-Saharan Africa (all income levels) in 2006 to that in 2007?
Offer a very short reply. 1.03. What is the ratio of the Persistence rate to the last grade of primary education (%) of Latvia in 2006 to that in 2007?
Your answer should be very brief. 1. What is the ratio of the Persistence rate to the last grade of primary education (%) of Zambia in 2006 to that in 2007?
Your answer should be compact. 1.01. What is the ratio of the Persistence rate to the last grade of primary education (%) of Small states in 2006 to that in 2008?
Offer a very short reply. 0.97. What is the ratio of the Persistence rate to the last grade of primary education (%) in Sub-Saharan Africa (all income levels) in 2006 to that in 2008?
Ensure brevity in your answer.  0.99. What is the ratio of the Persistence rate to the last grade of primary education (%) in Latvia in 2006 to that in 2008?
Offer a very short reply. 1.02. What is the ratio of the Persistence rate to the last grade of primary education (%) in Zambia in 2006 to that in 2008?
Keep it short and to the point. 1.52. What is the ratio of the Persistence rate to the last grade of primary education (%) of Small states in 2006 to that in 2012?
Keep it short and to the point. 0.96. What is the ratio of the Persistence rate to the last grade of primary education (%) of Sub-Saharan Africa (all income levels) in 2006 to that in 2012?
Ensure brevity in your answer.  1.04. What is the ratio of the Persistence rate to the last grade of primary education (%) in Latvia in 2006 to that in 2012?
Keep it short and to the point. 1.05. What is the ratio of the Persistence rate to the last grade of primary education (%) in Zambia in 2006 to that in 2012?
Provide a succinct answer. 1.45. What is the ratio of the Persistence rate to the last grade of primary education (%) in Small states in 2007 to that in 2008?
Provide a short and direct response. 1.01. What is the ratio of the Persistence rate to the last grade of primary education (%) of Sub-Saharan Africa (all income levels) in 2007 to that in 2008?
Offer a terse response. 0.96. What is the ratio of the Persistence rate to the last grade of primary education (%) in Latvia in 2007 to that in 2008?
Your response must be concise. 1.01. What is the ratio of the Persistence rate to the last grade of primary education (%) in Zambia in 2007 to that in 2008?
Provide a short and direct response. 1.49. What is the ratio of the Persistence rate to the last grade of primary education (%) of Sub-Saharan Africa (all income levels) in 2007 to that in 2012?
Ensure brevity in your answer.  1.01. What is the ratio of the Persistence rate to the last grade of primary education (%) in Latvia in 2007 to that in 2012?
Offer a very short reply. 1.05. What is the ratio of the Persistence rate to the last grade of primary education (%) of Zambia in 2007 to that in 2012?
Your answer should be very brief. 1.42. What is the ratio of the Persistence rate to the last grade of primary education (%) of Small states in 2008 to that in 2012?
Your response must be concise. 0.98. What is the ratio of the Persistence rate to the last grade of primary education (%) of Sub-Saharan Africa (all income levels) in 2008 to that in 2012?
Your answer should be compact. 1.05. What is the ratio of the Persistence rate to the last grade of primary education (%) of Latvia in 2008 to that in 2012?
Your response must be concise. 1.03. What is the ratio of the Persistence rate to the last grade of primary education (%) of Zambia in 2008 to that in 2012?
Your response must be concise. 0.95. What is the difference between the highest and the second highest Persistence rate to the last grade of primary education (%) in Small states?
Offer a terse response. 0.59. What is the difference between the highest and the second highest Persistence rate to the last grade of primary education (%) in Sub-Saharan Africa (all income levels)?
Offer a terse response. 2.18. What is the difference between the highest and the second highest Persistence rate to the last grade of primary education (%) in Latvia?
Your answer should be very brief. 0.72. What is the difference between the highest and the second highest Persistence rate to the last grade of primary education (%) in Zambia?
Offer a very short reply. 1.2. What is the difference between the highest and the lowest Persistence rate to the last grade of primary education (%) of Small states?
Keep it short and to the point. 4.72. What is the difference between the highest and the lowest Persistence rate to the last grade of primary education (%) of Sub-Saharan Africa (all income levels)?
Keep it short and to the point. 5.8. What is the difference between the highest and the lowest Persistence rate to the last grade of primary education (%) of Latvia?
Your answer should be very brief. 5.23. What is the difference between the highest and the lowest Persistence rate to the last grade of primary education (%) of Zambia?
Offer a very short reply. 28.2. 